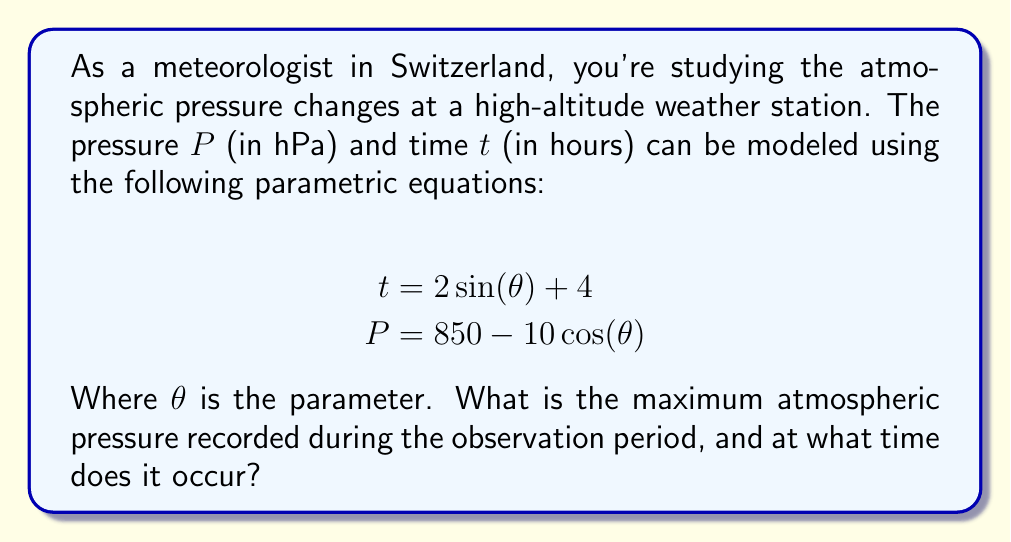Could you help me with this problem? To solve this problem, we need to follow these steps:

1) First, we need to find the maximum value of $P$. From the equation $P = 850 - 10\cos(\theta)$, we can see that $P$ will be at its maximum when $\cos(\theta)$ is at its minimum.

2) We know that the minimum value of cosine is -1, which occurs when $\theta = \pi$ (or odd multiples of $\pi$).

3) Therefore, the maximum pressure is:
   $$P_{max} = 850 - 10(-1) = 850 + 10 = 860 \text{ hPa}$$

4) Now we need to find the time when this maximum pressure occurs. We substitute $\theta = \pi$ into the equation for $t$:
   $$t = 2\sin(\pi) + 4 = 2(0) + 4 = 4 \text{ hours}$$

5) To verify this is indeed the maximum, we can check the pressure at $t = 4$ hours:
   $$\begin{align*}
   4 &= 2\sin(\theta) + 4 \\
   0 &= 2\sin(\theta) \\
   \theta &= \pi
   \end{align*}$$

   Which confirms our earlier finding.

Therefore, the maximum pressure of 860 hPa occurs at t = 4 hours.
Answer: The maximum atmospheric pressure is 860 hPa, occurring at t = 4 hours. 